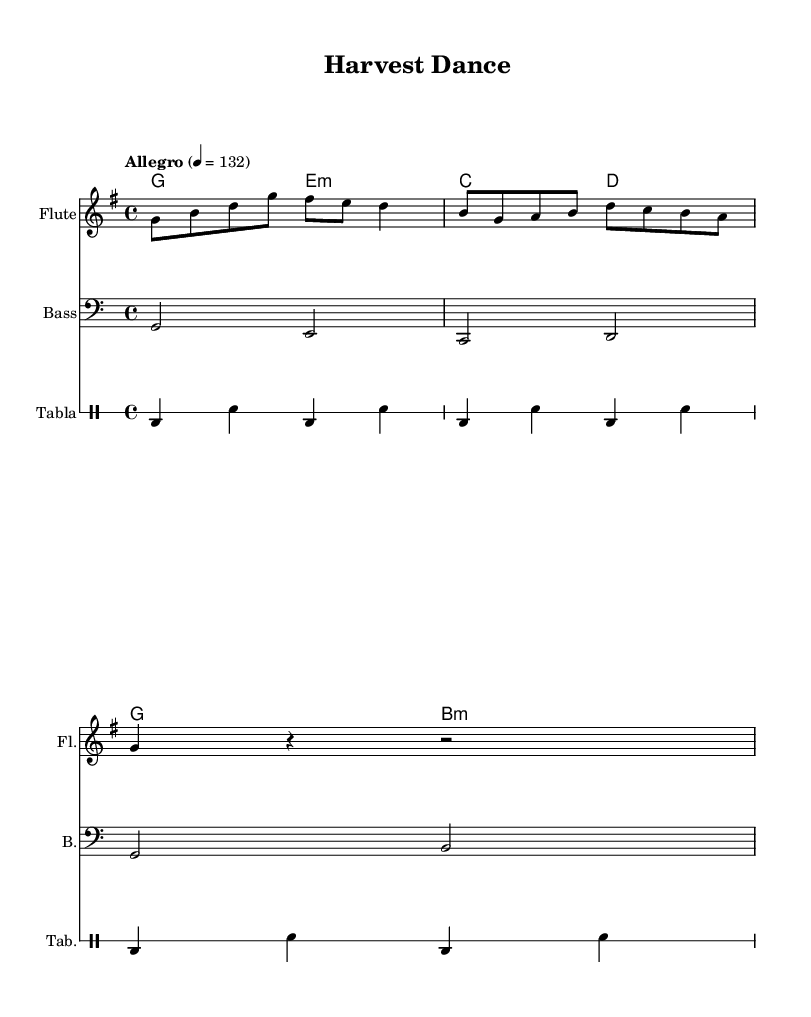What is the key signature of this music? The key signature is G major, which has one sharp (F#). It can be identified by looking at the beginning of the staff where the sharps are indicated.
Answer: G major What is the time signature of this music? The time signature is 4/4, which means there are four beats per measure, and the quarter note gets one beat. This can be seen on the beginning of the staff, just to the right of the key signature.
Answer: 4/4 What is the tempo marking of this music? The tempo marking is "Allegro" at a speed of 132 beats per minute. This is indicated at the beginning of the score, specifying how fast the piece should be played.
Answer: Allegro 132 How many measures does the melody contain? The melody, based on the visual representation of the notes, appears to contain three measures. Counting from the start to the end, we can verify this count by identifying the measure lines.
Answer: 3 Which instruments are featured in this piece? The instruments featured in this piece are flute, bass, and tabla. Each instrument is listed at the beginning of its respective staff, indicating the instruments used in the performance.
Answer: Flute, Bass, Tabla What rhythm pattern is given for the tabla? The rhythm pattern for the tabla consists of a repeating pattern of bass and snare hits represented by 'bd' for bass drum and 'sn' for snare drum. This can be verified by examining the drum notation within the drum staff.
Answer: bd4 sn What type of dance could this music be suitable for? The upbeat and lively nature of the music, along with the traditional instrumentation of flute and tabla, suggests it could be suitable for a Harvest Dance. This conclusion can be drawn from the cultural roots and rhythmic patterns of the piece.
Answer: Harvest Dance 